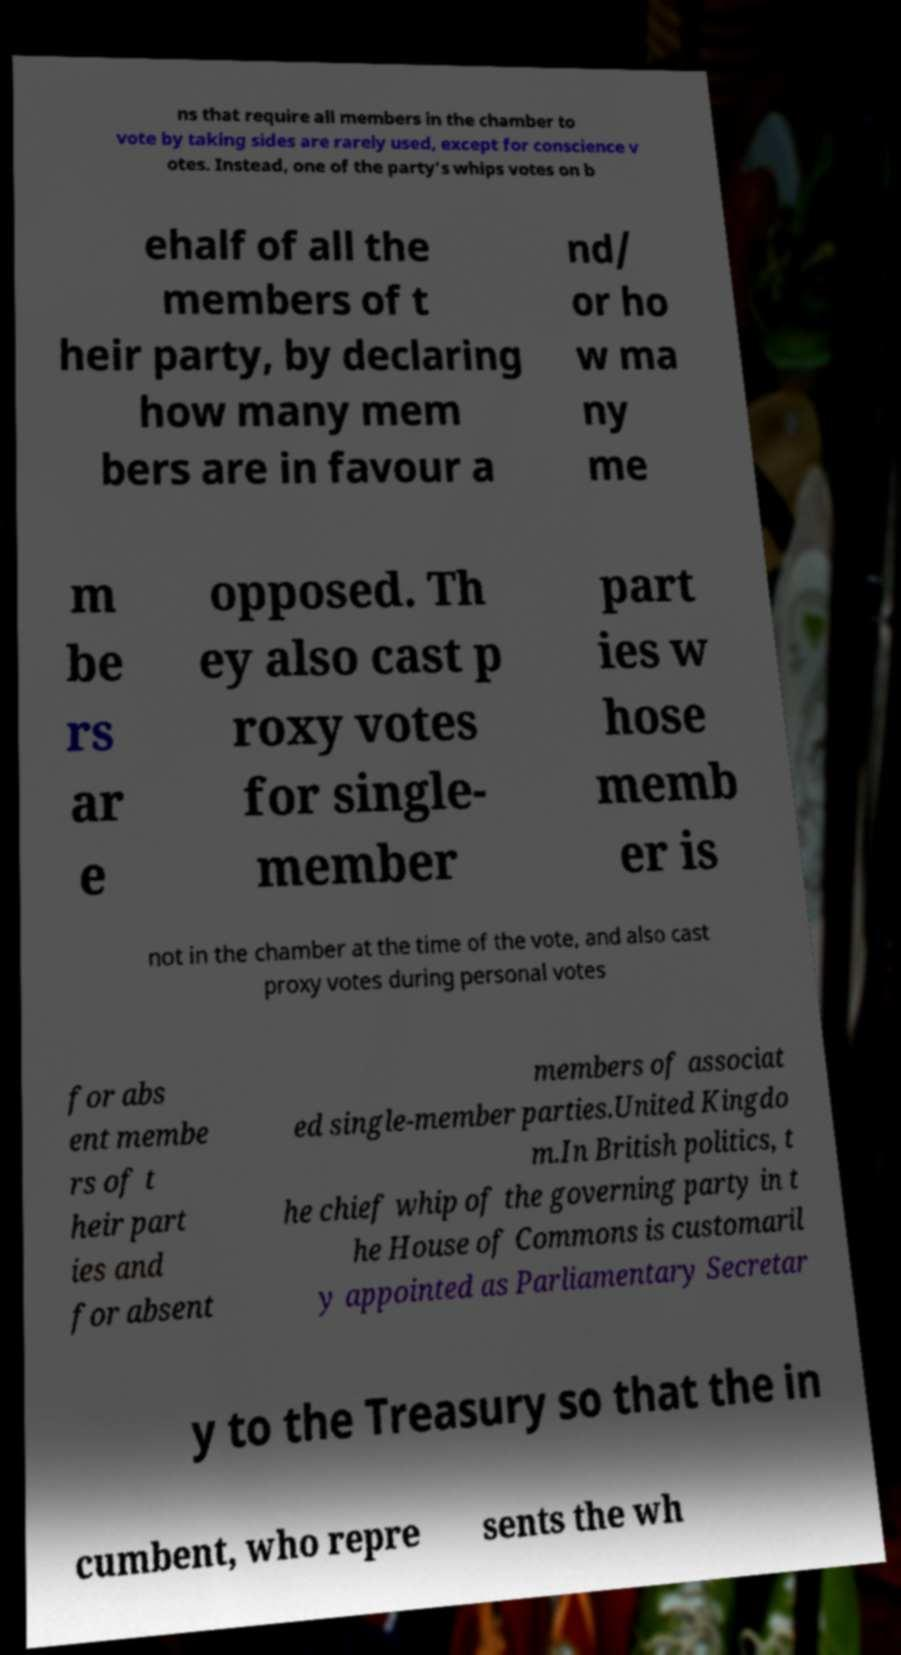What messages or text are displayed in this image? I need them in a readable, typed format. ns that require all members in the chamber to vote by taking sides are rarely used, except for conscience v otes. Instead, one of the party's whips votes on b ehalf of all the members of t heir party, by declaring how many mem bers are in favour a nd/ or ho w ma ny me m be rs ar e opposed. Th ey also cast p roxy votes for single- member part ies w hose memb er is not in the chamber at the time of the vote, and also cast proxy votes during personal votes for abs ent membe rs of t heir part ies and for absent members of associat ed single-member parties.United Kingdo m.In British politics, t he chief whip of the governing party in t he House of Commons is customaril y appointed as Parliamentary Secretar y to the Treasury so that the in cumbent, who repre sents the wh 